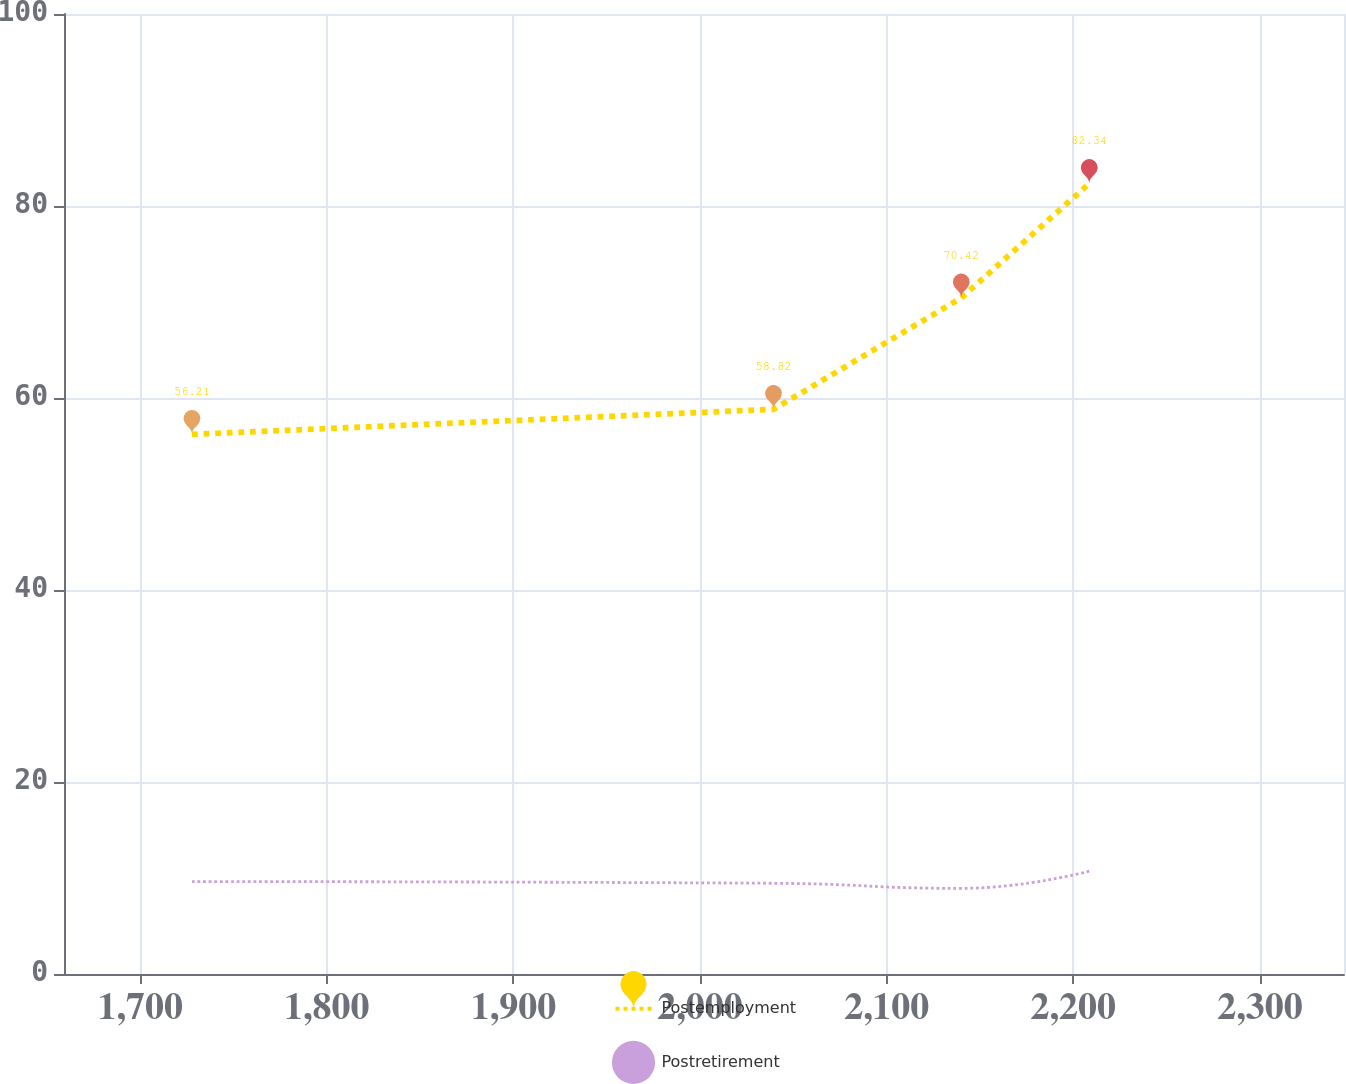Convert chart to OTSL. <chart><loc_0><loc_0><loc_500><loc_500><line_chart><ecel><fcel>Postemployment<fcel>Postretirement<nl><fcel>1727.79<fcel>56.21<fcel>9.63<nl><fcel>2039.36<fcel>58.82<fcel>9.45<nl><fcel>2139.92<fcel>70.42<fcel>8.92<nl><fcel>2208.5<fcel>82.34<fcel>10.71<nl><fcel>2413.57<fcel>67.81<fcel>10.19<nl></chart> 